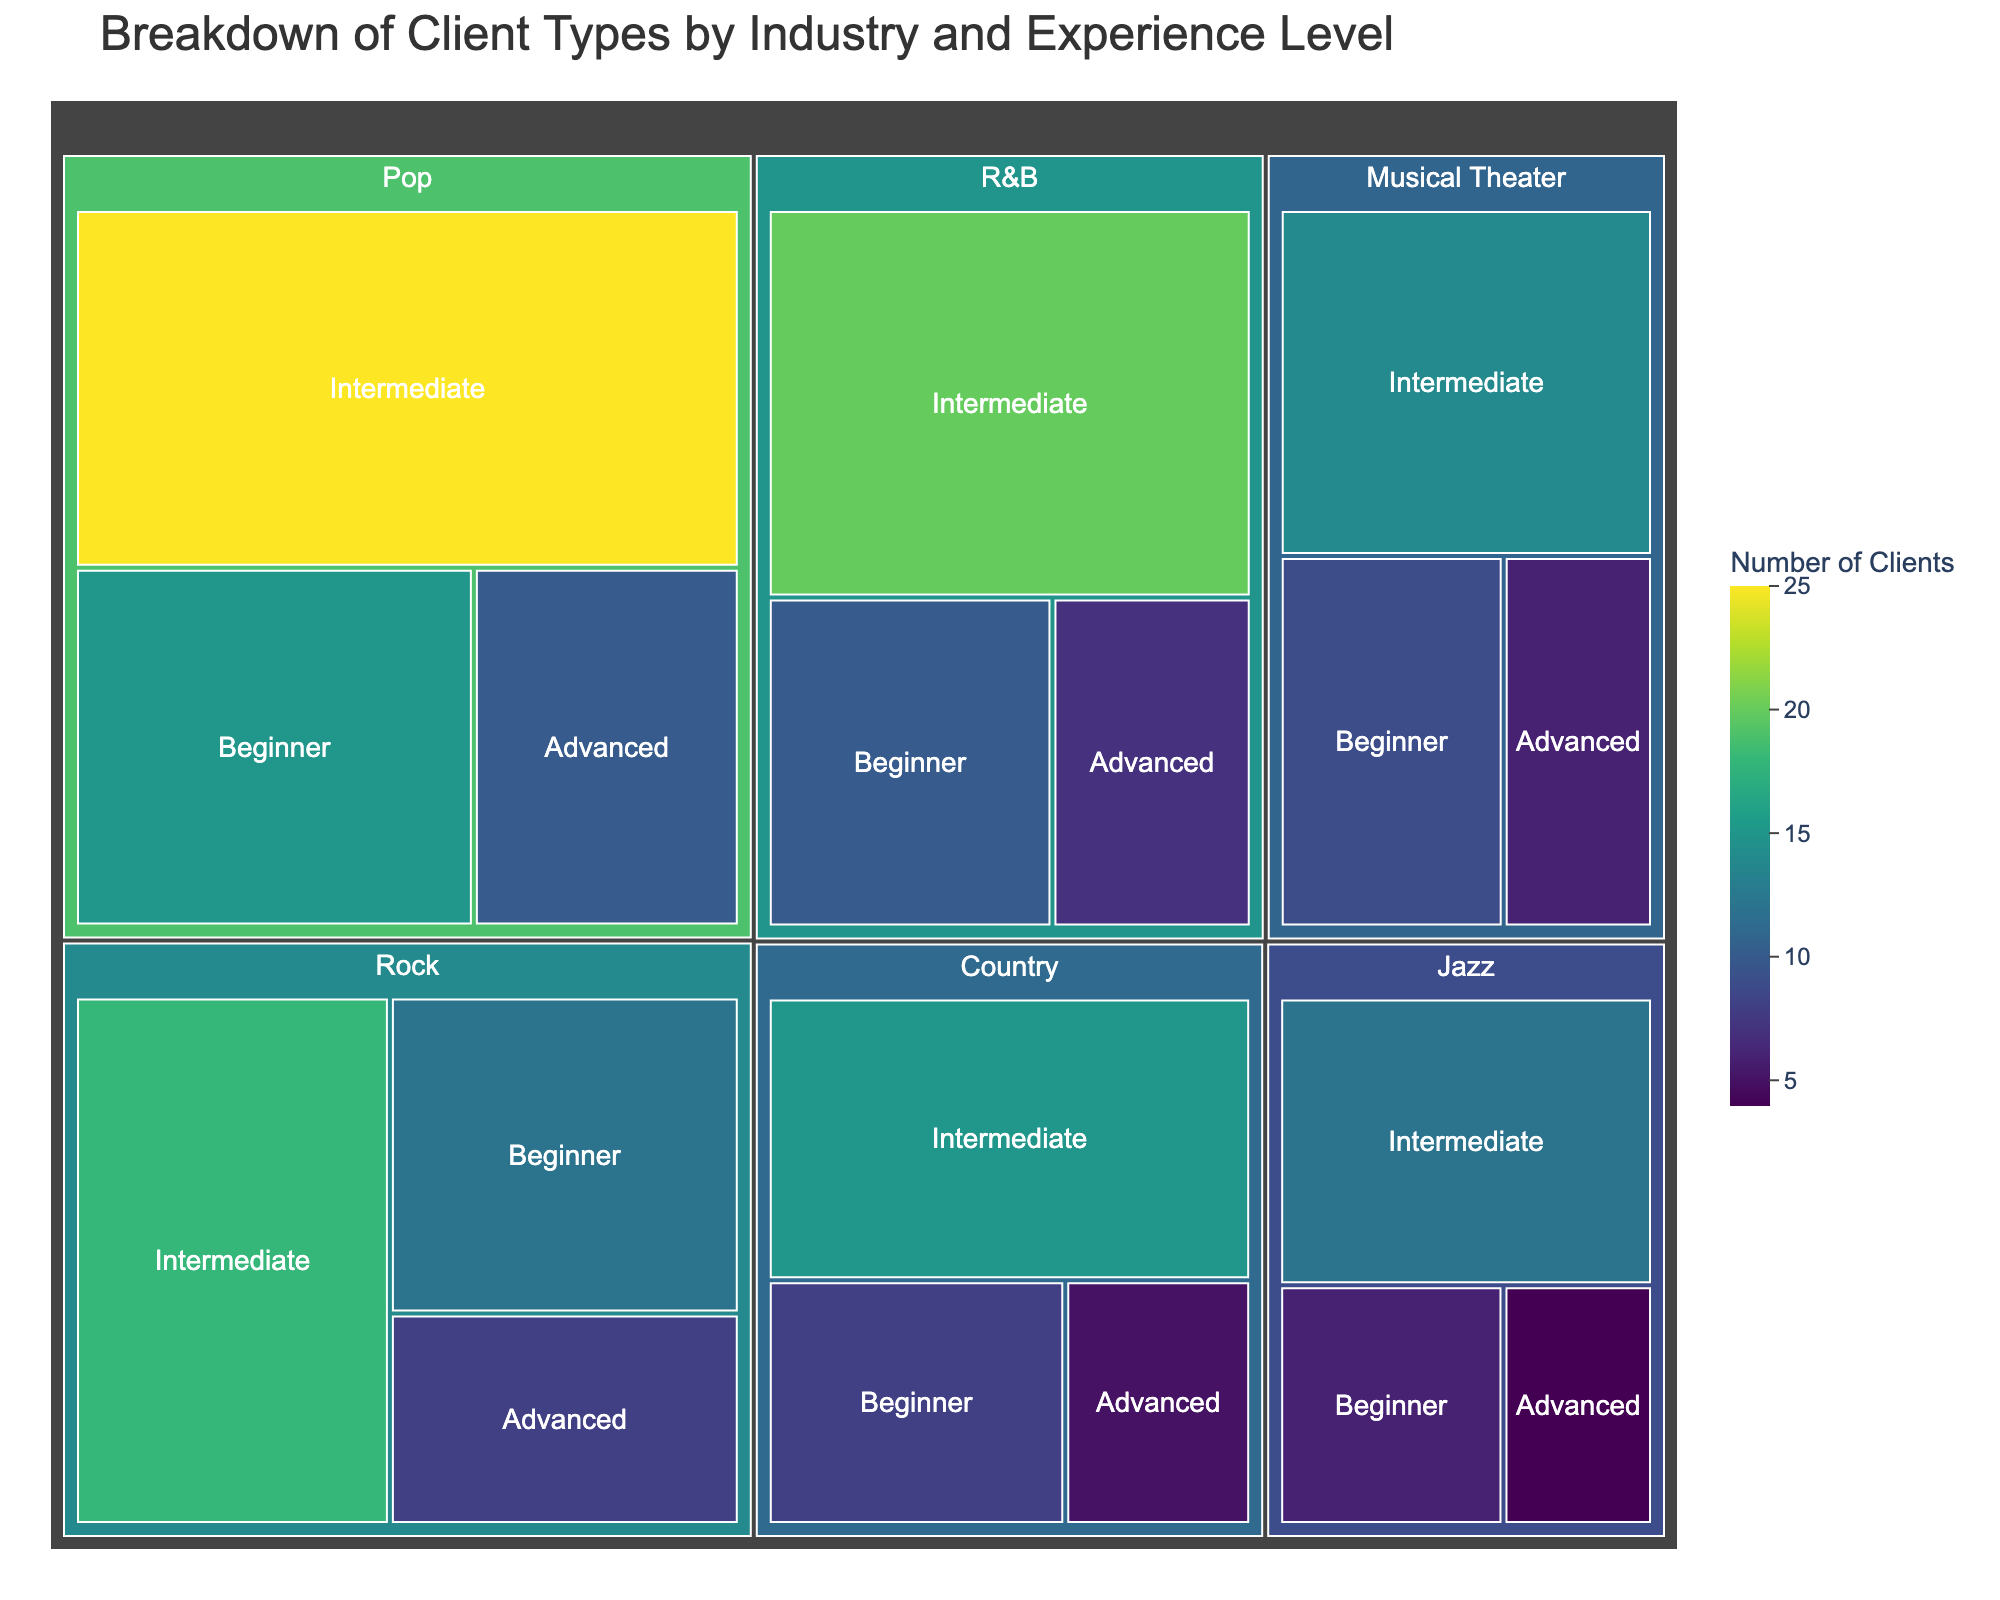What is the title of the figure? The title is displayed at the top of the treemap. It is labeled as "Breakdown of Client Types by Industry and Experience Level."
Answer: Breakdown of Client Types by Industry and Experience Level Which industry has the highest number of clients overall? In the treemap, the largest portion is allocated to the Pop industry, indicating it has the highest number of clients.
Answer: Pop How many clients are beginners in the Rock industry? Locate the Rock industry section and identify the part labeled "Beginner." The number indicates 12.
Answer: 12 Which experience level in the Jazz industry has the fewest clients? In the Jazz section, the "Advanced" level has the smallest box, showing 4 clients.
Answer: Advanced What is the total number of clients in the Country industry? Add clients from all experience levels in the Country industry: Beginner (8) + Intermediate (15) + Advanced (5) = 28.
Answer: 28 How do the number of intermediate clients in Pop compare to the number of beginner clients in R&B? The number of intermediate clients in Pop is 25, and the number of beginner clients in R&B is 10. Since 25 is greater than 10, Pop has more intermediate clients.
Answer: Pop has more Which industry has the most beginner-level clients? Compare the beginner sections in all industries. The Pop industry has the largest beginner section with 15 clients.
Answer: Pop What is the difference in client numbers between intermediate and advanced levels in Musical Theater? In the Musical Theater section: Intermediate (14) - Advanced (6) = 8.
Answer: 8 How many more clients are there at the intermediate level in the Jazz industry compared to the beginner level? In the Jazz section: Intermediate (12) - Beginner (6) = 6.
Answer: 6 Which industry has an equal number of beginner and intermediate clients? No sections have visually equal beginner and intermediate client numbers.
Answer: None 